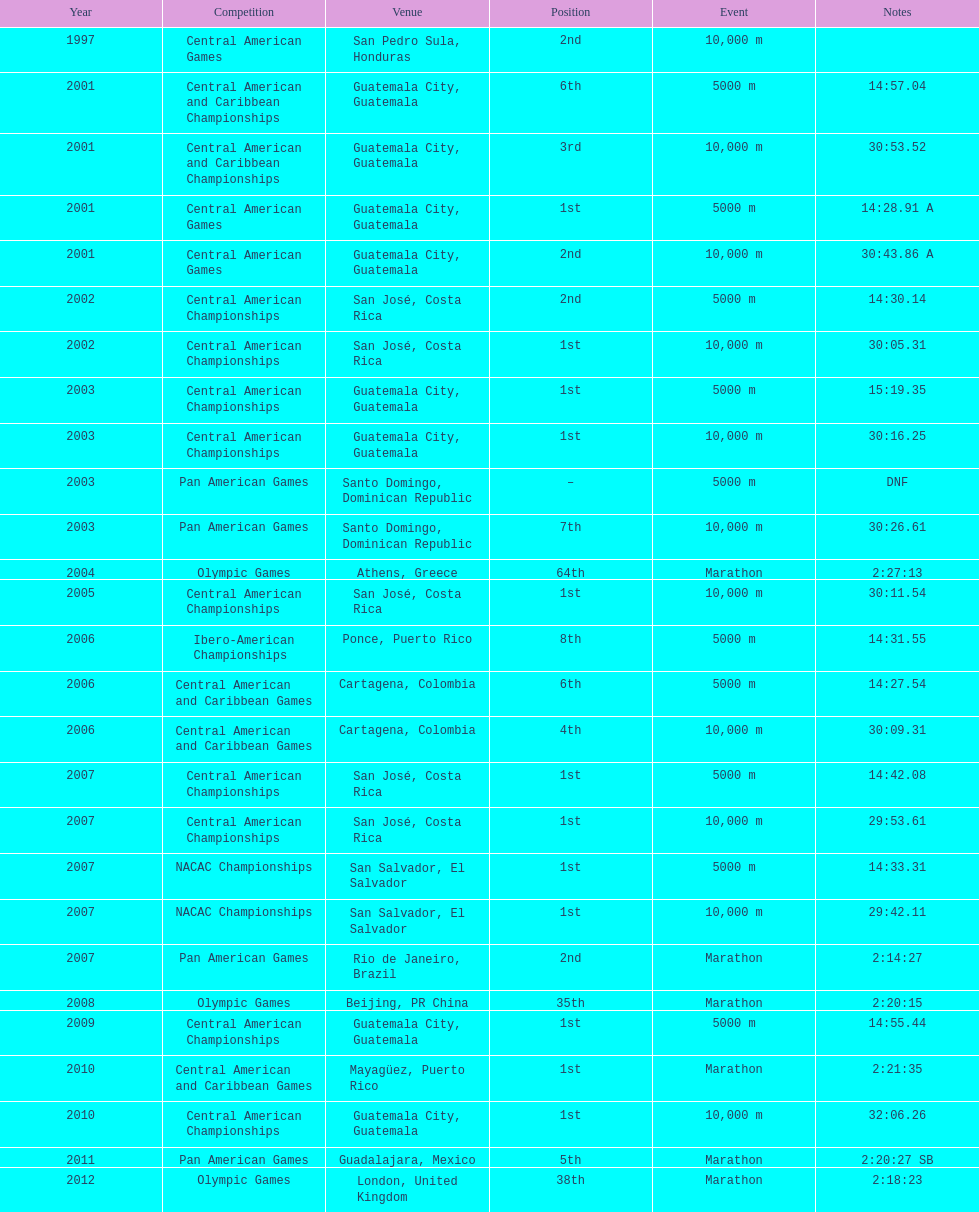In the latest competition, when was a standing of "2nd" secured? Pan American Games. 